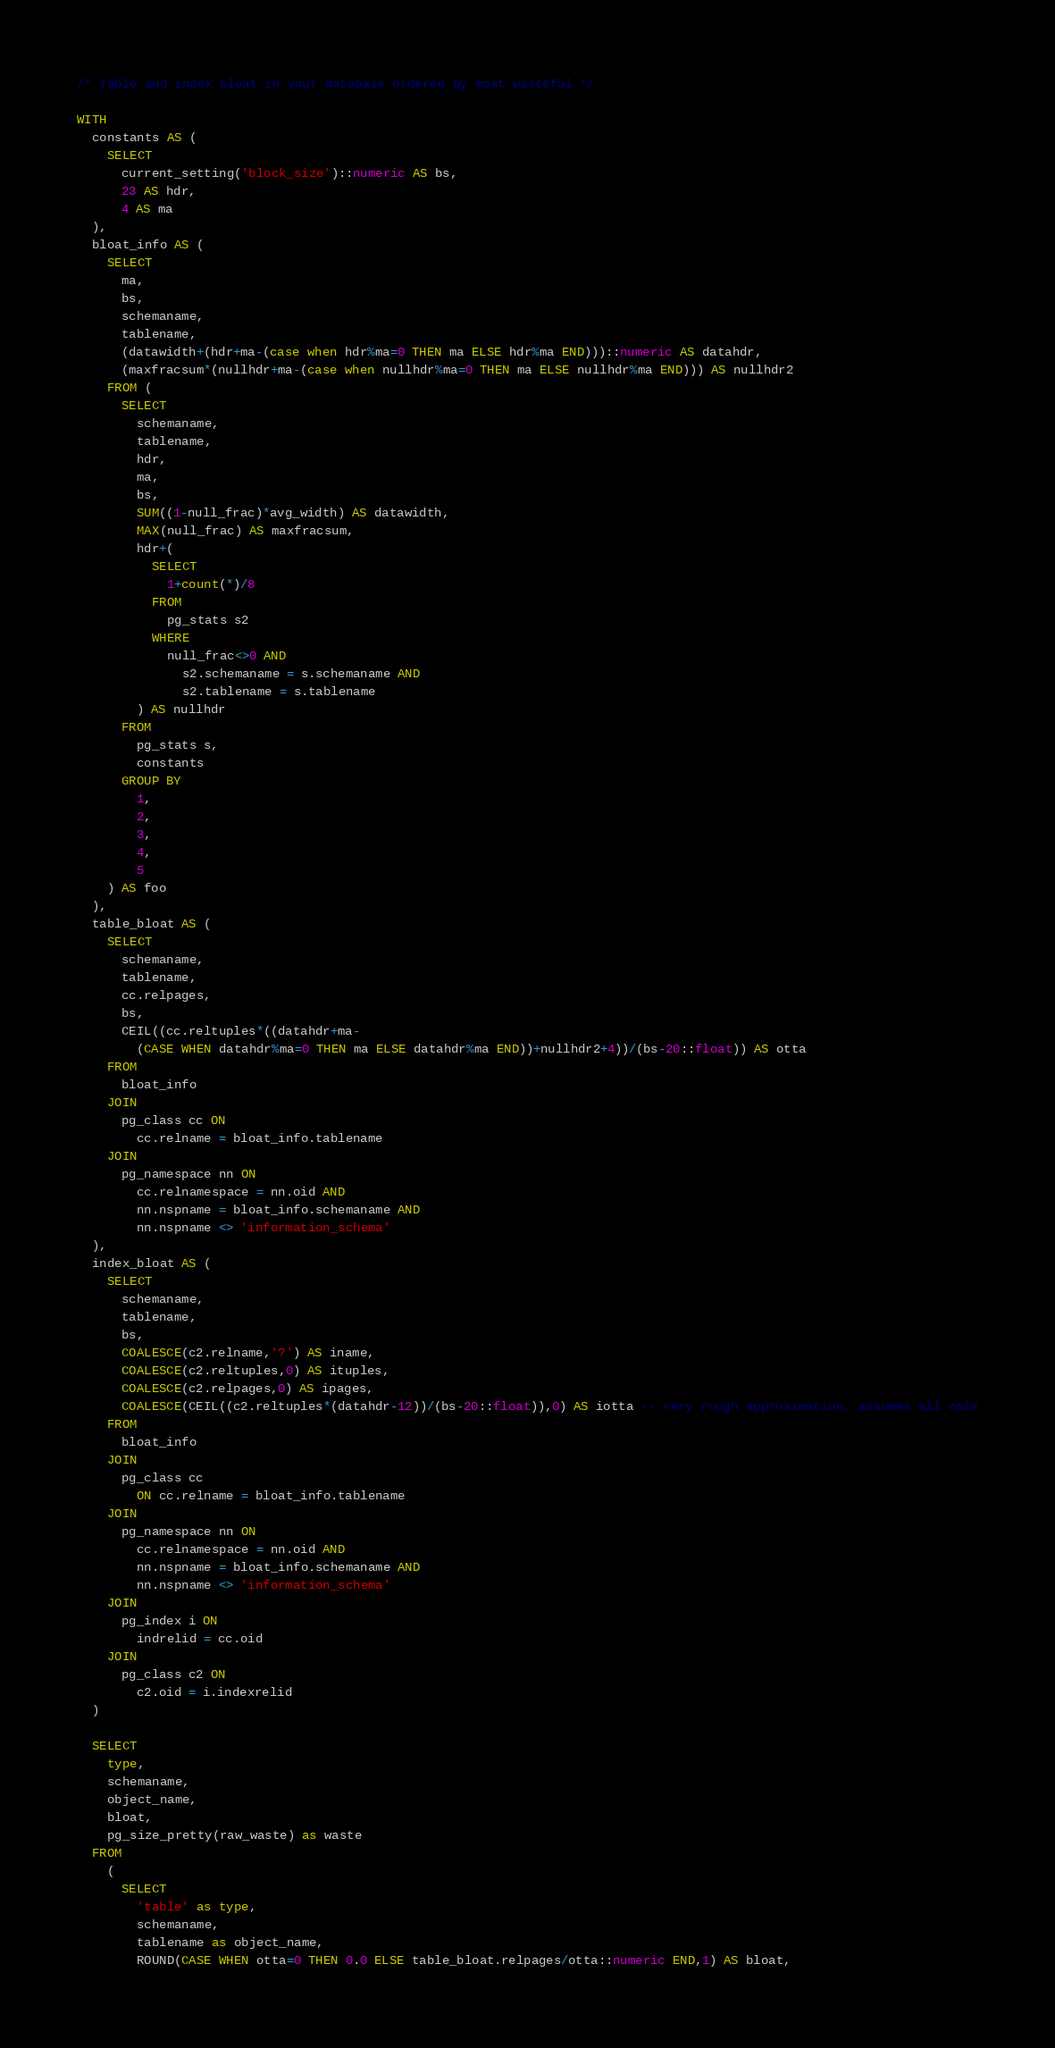Convert code to text. <code><loc_0><loc_0><loc_500><loc_500><_SQL_>/* Table and index bloat in your database ordered by most wasteful */

WITH
  constants AS (
    SELECT
      current_setting('block_size')::numeric AS bs,
      23 AS hdr,
      4 AS ma
  ),
  bloat_info AS (
    SELECT
      ma,
      bs,
      schemaname,
      tablename,
      (datawidth+(hdr+ma-(case when hdr%ma=0 THEN ma ELSE hdr%ma END)))::numeric AS datahdr,
      (maxfracsum*(nullhdr+ma-(case when nullhdr%ma=0 THEN ma ELSE nullhdr%ma END))) AS nullhdr2
    FROM (
      SELECT
        schemaname,
        tablename,
        hdr,
        ma,
        bs,
        SUM((1-null_frac)*avg_width) AS datawidth,
        MAX(null_frac) AS maxfracsum,
        hdr+(
          SELECT
            1+count(*)/8
          FROM
            pg_stats s2
          WHERE
            null_frac<>0 AND
              s2.schemaname = s.schemaname AND
              s2.tablename = s.tablename
        ) AS nullhdr
      FROM
        pg_stats s,
        constants
      GROUP BY
        1,
        2,
        3,
        4,
        5
    ) AS foo
  ),
  table_bloat AS (
    SELECT
      schemaname,
      tablename,
      cc.relpages,
      bs,
      CEIL((cc.reltuples*((datahdr+ma-
        (CASE WHEN datahdr%ma=0 THEN ma ELSE datahdr%ma END))+nullhdr2+4))/(bs-20::float)) AS otta
    FROM
      bloat_info
    JOIN
      pg_class cc ON
        cc.relname = bloat_info.tablename
    JOIN
      pg_namespace nn ON
        cc.relnamespace = nn.oid AND
        nn.nspname = bloat_info.schemaname AND
        nn.nspname <> 'information_schema'
  ),
  index_bloat AS (
    SELECT
      schemaname,
      tablename,
      bs,
      COALESCE(c2.relname,'?') AS iname,
      COALESCE(c2.reltuples,0) AS ituples,
      COALESCE(c2.relpages,0) AS ipages,
      COALESCE(CEIL((c2.reltuples*(datahdr-12))/(bs-20::float)),0) AS iotta -- very rough approximation, assumes all cols
    FROM
      bloat_info
    JOIN
      pg_class cc
        ON cc.relname = bloat_info.tablename
    JOIN
      pg_namespace nn ON
        cc.relnamespace = nn.oid AND
        nn.nspname = bloat_info.schemaname AND
        nn.nspname <> 'information_schema'
    JOIN
      pg_index i ON
        indrelid = cc.oid
    JOIN
      pg_class c2 ON
        c2.oid = i.indexrelid
  )

  SELECT
    type,
    schemaname,
    object_name,
    bloat,
    pg_size_pretty(raw_waste) as waste
  FROM
    (
      SELECT
        'table' as type,
        schemaname,
        tablename as object_name,
        ROUND(CASE WHEN otta=0 THEN 0.0 ELSE table_bloat.relpages/otta::numeric END,1) AS bloat,</code> 